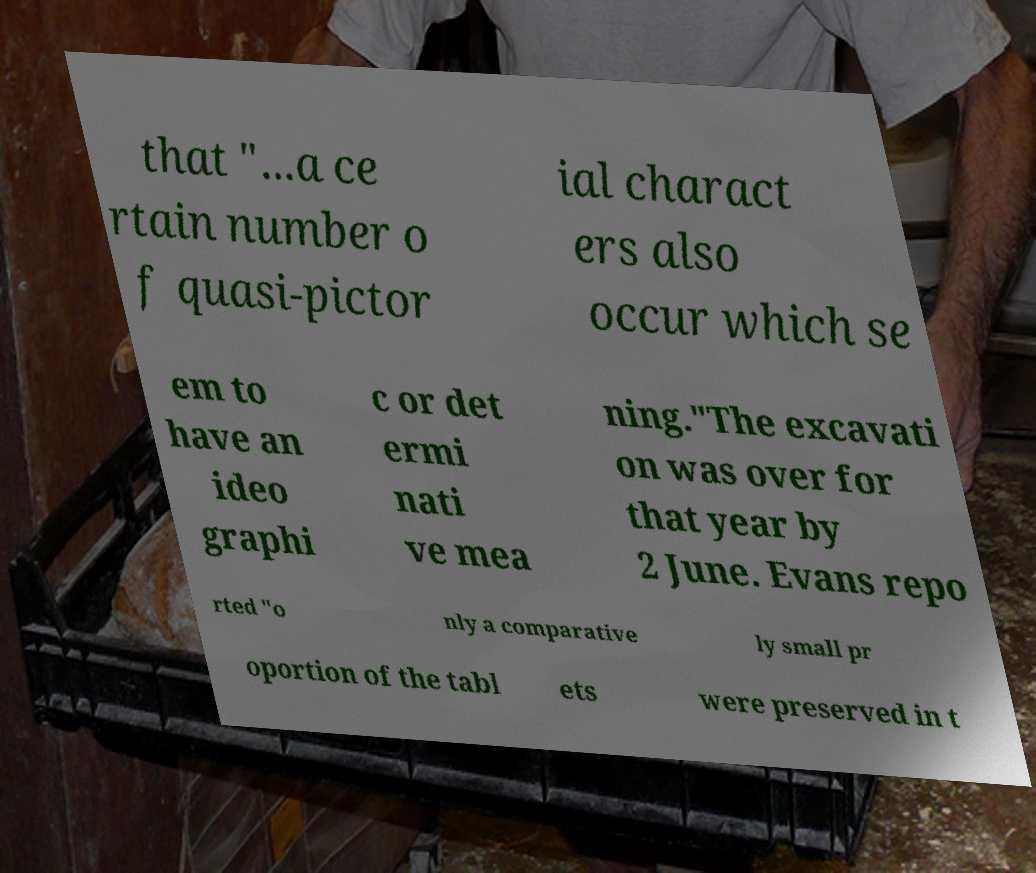I need the written content from this picture converted into text. Can you do that? that "...a ce rtain number o f quasi-pictor ial charact ers also occur which se em to have an ideo graphi c or det ermi nati ve mea ning."The excavati on was over for that year by 2 June. Evans repo rted "o nly a comparative ly small pr oportion of the tabl ets were preserved in t 